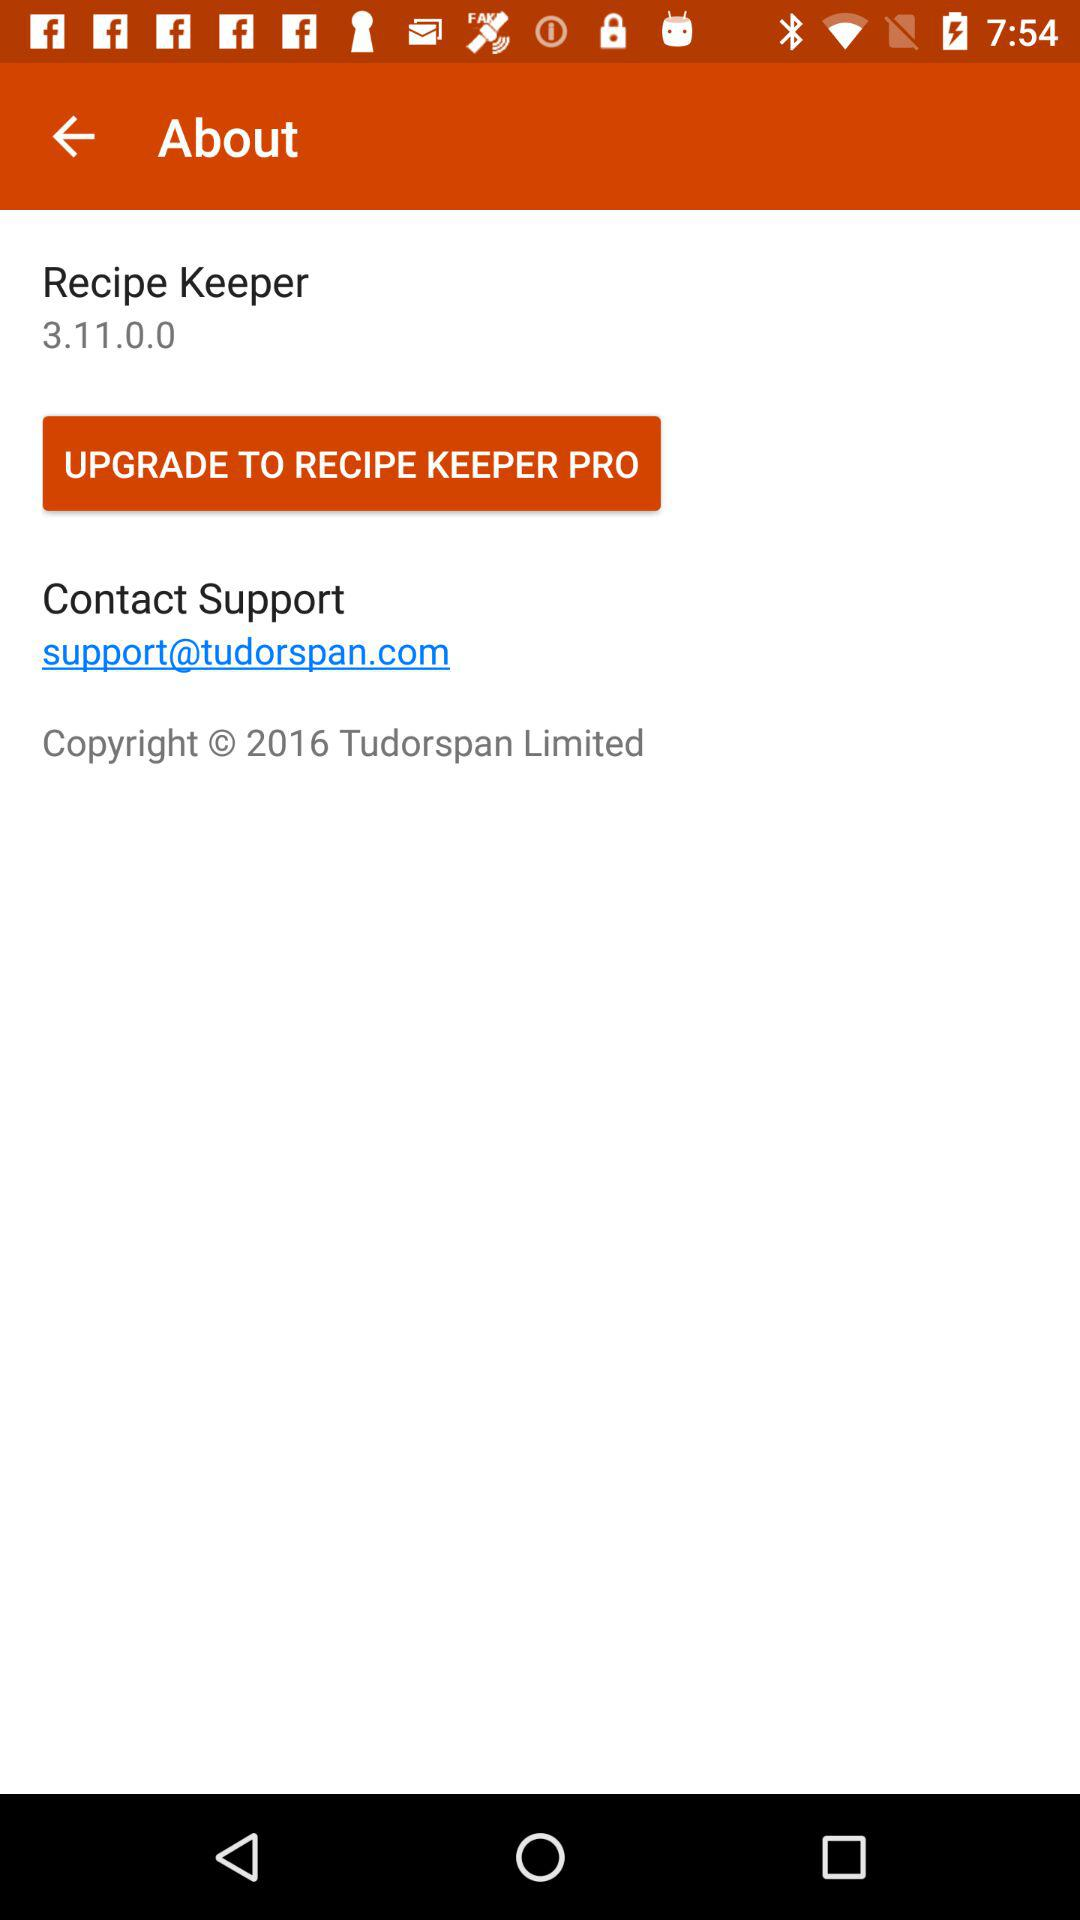What is the version of "Recipe Keeper"? The version is 3.11.0.0. 